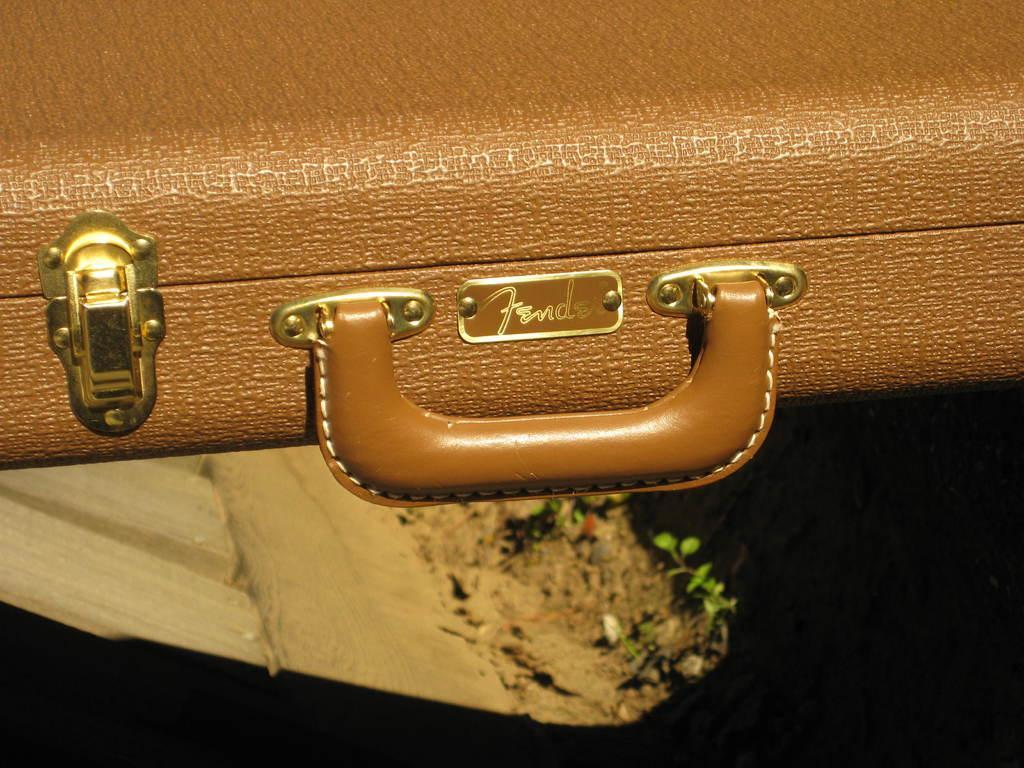Please provide a concise description of this image. In this image we can see a handbag. This is a locker on the left side and this is a handle which is in the center. 